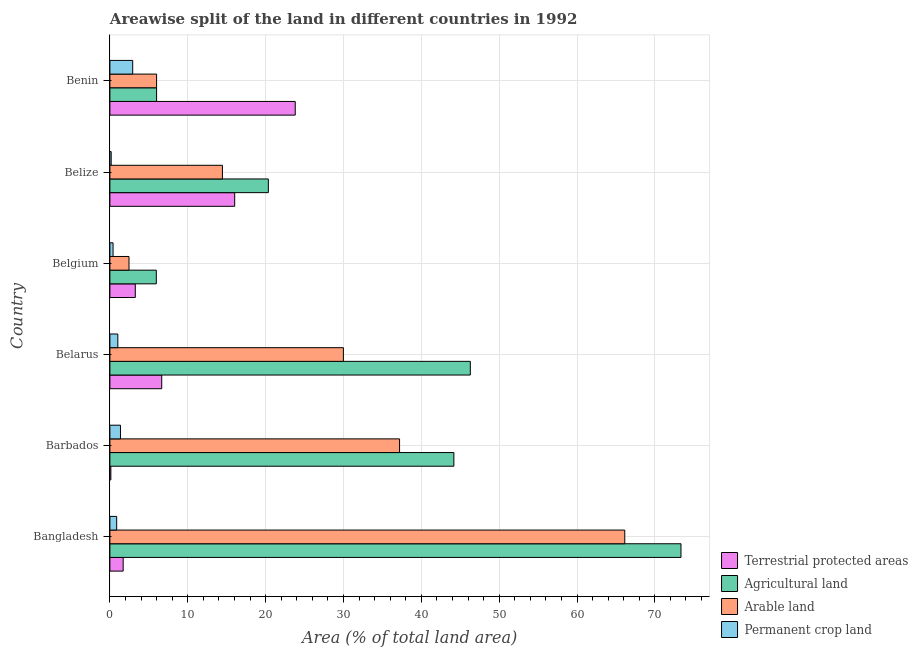How many groups of bars are there?
Provide a succinct answer. 6. Are the number of bars per tick equal to the number of legend labels?
Give a very brief answer. Yes. Are the number of bars on each tick of the Y-axis equal?
Your response must be concise. Yes. What is the label of the 2nd group of bars from the top?
Give a very brief answer. Belize. In how many cases, is the number of bars for a given country not equal to the number of legend labels?
Make the answer very short. 0. What is the percentage of area under permanent crop land in Belgium?
Ensure brevity in your answer.  0.41. Across all countries, what is the maximum percentage of area under permanent crop land?
Offer a very short reply. 2.93. Across all countries, what is the minimum percentage of area under agricultural land?
Keep it short and to the point. 5.96. In which country was the percentage of area under permanent crop land maximum?
Keep it short and to the point. Benin. In which country was the percentage of area under agricultural land minimum?
Offer a terse response. Belgium. What is the total percentage of area under agricultural land in the graph?
Your answer should be compact. 196.16. What is the difference between the percentage of area under agricultural land in Belize and that in Benin?
Keep it short and to the point. 14.35. What is the difference between the percentage of land under terrestrial protection in Benin and the percentage of area under permanent crop land in Barbados?
Provide a succinct answer. 22.45. What is the average percentage of area under arable land per country?
Give a very brief answer. 26.04. What is the difference between the percentage of area under permanent crop land and percentage of land under terrestrial protection in Bangladesh?
Your answer should be very brief. -0.83. What is the ratio of the percentage of area under agricultural land in Barbados to that in Belgium?
Give a very brief answer. 7.41. Is the percentage of area under arable land in Bangladesh less than that in Barbados?
Your response must be concise. No. Is the difference between the percentage of area under agricultural land in Bangladesh and Belize greater than the difference between the percentage of land under terrestrial protection in Bangladesh and Belize?
Provide a succinct answer. Yes. What is the difference between the highest and the second highest percentage of area under agricultural land?
Make the answer very short. 27.06. What is the difference between the highest and the lowest percentage of area under arable land?
Your answer should be very brief. 63.68. In how many countries, is the percentage of area under arable land greater than the average percentage of area under arable land taken over all countries?
Your answer should be very brief. 3. What does the 1st bar from the top in Barbados represents?
Your response must be concise. Permanent crop land. What does the 2nd bar from the bottom in Belarus represents?
Make the answer very short. Agricultural land. How many bars are there?
Give a very brief answer. 24. Are all the bars in the graph horizontal?
Offer a very short reply. Yes. How many countries are there in the graph?
Ensure brevity in your answer.  6. What is the difference between two consecutive major ticks on the X-axis?
Provide a short and direct response. 10. Does the graph contain any zero values?
Offer a very short reply. No. Does the graph contain grids?
Your answer should be compact. Yes. Where does the legend appear in the graph?
Give a very brief answer. Bottom right. What is the title of the graph?
Keep it short and to the point. Areawise split of the land in different countries in 1992. Does "Building human resources" appear as one of the legend labels in the graph?
Your response must be concise. No. What is the label or title of the X-axis?
Ensure brevity in your answer.  Area (% of total land area). What is the Area (% of total land area) of Terrestrial protected areas in Bangladesh?
Offer a very short reply. 1.71. What is the Area (% of total land area) of Agricultural land in Bangladesh?
Provide a short and direct response. 73.36. What is the Area (% of total land area) of Arable land in Bangladesh?
Keep it short and to the point. 66.14. What is the Area (% of total land area) of Permanent crop land in Bangladesh?
Make the answer very short. 0.87. What is the Area (% of total land area) in Terrestrial protected areas in Barbados?
Your answer should be compact. 0.12. What is the Area (% of total land area) of Agricultural land in Barbados?
Keep it short and to the point. 44.19. What is the Area (% of total land area) of Arable land in Barbados?
Make the answer very short. 37.21. What is the Area (% of total land area) of Permanent crop land in Barbados?
Your answer should be very brief. 1.36. What is the Area (% of total land area) of Terrestrial protected areas in Belarus?
Provide a short and direct response. 6.66. What is the Area (% of total land area) of Agricultural land in Belarus?
Keep it short and to the point. 46.3. What is the Area (% of total land area) of Arable land in Belarus?
Keep it short and to the point. 29.99. What is the Area (% of total land area) in Permanent crop land in Belarus?
Provide a short and direct response. 1.02. What is the Area (% of total land area) in Terrestrial protected areas in Belgium?
Provide a short and direct response. 3.26. What is the Area (% of total land area) in Agricultural land in Belgium?
Offer a very short reply. 5.96. What is the Area (% of total land area) in Arable land in Belgium?
Your answer should be very brief. 2.46. What is the Area (% of total land area) of Permanent crop land in Belgium?
Keep it short and to the point. 0.41. What is the Area (% of total land area) of Terrestrial protected areas in Belize?
Provide a short and direct response. 16.03. What is the Area (% of total land area) in Agricultural land in Belize?
Ensure brevity in your answer.  20.35. What is the Area (% of total land area) in Arable land in Belize?
Ensure brevity in your answer.  14.46. What is the Area (% of total land area) of Permanent crop land in Belize?
Make the answer very short. 0.17. What is the Area (% of total land area) in Terrestrial protected areas in Benin?
Your response must be concise. 23.81. What is the Area (% of total land area) in Agricultural land in Benin?
Your answer should be very brief. 6. What is the Area (% of total land area) in Permanent crop land in Benin?
Offer a terse response. 2.93. Across all countries, what is the maximum Area (% of total land area) of Terrestrial protected areas?
Your answer should be compact. 23.81. Across all countries, what is the maximum Area (% of total land area) in Agricultural land?
Ensure brevity in your answer.  73.36. Across all countries, what is the maximum Area (% of total land area) of Arable land?
Offer a very short reply. 66.14. Across all countries, what is the maximum Area (% of total land area) of Permanent crop land?
Ensure brevity in your answer.  2.93. Across all countries, what is the minimum Area (% of total land area) of Terrestrial protected areas?
Keep it short and to the point. 0.12. Across all countries, what is the minimum Area (% of total land area) in Agricultural land?
Offer a very short reply. 5.96. Across all countries, what is the minimum Area (% of total land area) in Arable land?
Provide a succinct answer. 2.46. Across all countries, what is the minimum Area (% of total land area) in Permanent crop land?
Your answer should be compact. 0.17. What is the total Area (% of total land area) in Terrestrial protected areas in the graph?
Ensure brevity in your answer.  51.59. What is the total Area (% of total land area) of Agricultural land in the graph?
Give a very brief answer. 196.16. What is the total Area (% of total land area) in Arable land in the graph?
Offer a terse response. 156.25. What is the total Area (% of total land area) of Permanent crop land in the graph?
Your response must be concise. 6.75. What is the difference between the Area (% of total land area) of Terrestrial protected areas in Bangladesh and that in Barbados?
Make the answer very short. 1.58. What is the difference between the Area (% of total land area) in Agricultural land in Bangladesh and that in Barbados?
Your answer should be very brief. 29.17. What is the difference between the Area (% of total land area) in Arable land in Bangladesh and that in Barbados?
Make the answer very short. 28.93. What is the difference between the Area (% of total land area) of Permanent crop land in Bangladesh and that in Barbados?
Your response must be concise. -0.49. What is the difference between the Area (% of total land area) in Terrestrial protected areas in Bangladesh and that in Belarus?
Keep it short and to the point. -4.95. What is the difference between the Area (% of total land area) in Agricultural land in Bangladesh and that in Belarus?
Your answer should be compact. 27.06. What is the difference between the Area (% of total land area) of Arable land in Bangladesh and that in Belarus?
Ensure brevity in your answer.  36.14. What is the difference between the Area (% of total land area) in Permanent crop land in Bangladesh and that in Belarus?
Give a very brief answer. -0.15. What is the difference between the Area (% of total land area) of Terrestrial protected areas in Bangladesh and that in Belgium?
Offer a very short reply. -1.56. What is the difference between the Area (% of total land area) in Agricultural land in Bangladesh and that in Belgium?
Give a very brief answer. 67.4. What is the difference between the Area (% of total land area) of Arable land in Bangladesh and that in Belgium?
Your answer should be very brief. 63.68. What is the difference between the Area (% of total land area) in Permanent crop land in Bangladesh and that in Belgium?
Ensure brevity in your answer.  0.47. What is the difference between the Area (% of total land area) of Terrestrial protected areas in Bangladesh and that in Belize?
Provide a short and direct response. -14.32. What is the difference between the Area (% of total land area) in Agricultural land in Bangladesh and that in Belize?
Provide a succinct answer. 53.01. What is the difference between the Area (% of total land area) of Arable land in Bangladesh and that in Belize?
Ensure brevity in your answer.  51.68. What is the difference between the Area (% of total land area) in Permanent crop land in Bangladesh and that in Belize?
Your response must be concise. 0.71. What is the difference between the Area (% of total land area) of Terrestrial protected areas in Bangladesh and that in Benin?
Offer a terse response. -22.1. What is the difference between the Area (% of total land area) in Agricultural land in Bangladesh and that in Benin?
Make the answer very short. 67.36. What is the difference between the Area (% of total land area) of Arable land in Bangladesh and that in Benin?
Your answer should be very brief. 60.14. What is the difference between the Area (% of total land area) in Permanent crop land in Bangladesh and that in Benin?
Offer a very short reply. -2.06. What is the difference between the Area (% of total land area) in Terrestrial protected areas in Barbados and that in Belarus?
Your answer should be compact. -6.54. What is the difference between the Area (% of total land area) in Agricultural land in Barbados and that in Belarus?
Make the answer very short. -2.11. What is the difference between the Area (% of total land area) in Arable land in Barbados and that in Belarus?
Provide a succinct answer. 7.22. What is the difference between the Area (% of total land area) in Permanent crop land in Barbados and that in Belarus?
Provide a short and direct response. 0.34. What is the difference between the Area (% of total land area) of Terrestrial protected areas in Barbados and that in Belgium?
Give a very brief answer. -3.14. What is the difference between the Area (% of total land area) in Agricultural land in Barbados and that in Belgium?
Your answer should be compact. 38.22. What is the difference between the Area (% of total land area) of Arable land in Barbados and that in Belgium?
Ensure brevity in your answer.  34.75. What is the difference between the Area (% of total land area) in Permanent crop land in Barbados and that in Belgium?
Keep it short and to the point. 0.95. What is the difference between the Area (% of total land area) in Terrestrial protected areas in Barbados and that in Belize?
Offer a terse response. -15.91. What is the difference between the Area (% of total land area) of Agricultural land in Barbados and that in Belize?
Ensure brevity in your answer.  23.83. What is the difference between the Area (% of total land area) of Arable land in Barbados and that in Belize?
Offer a very short reply. 22.75. What is the difference between the Area (% of total land area) of Permanent crop land in Barbados and that in Belize?
Provide a short and direct response. 1.19. What is the difference between the Area (% of total land area) in Terrestrial protected areas in Barbados and that in Benin?
Ensure brevity in your answer.  -23.68. What is the difference between the Area (% of total land area) in Agricultural land in Barbados and that in Benin?
Your answer should be very brief. 38.19. What is the difference between the Area (% of total land area) in Arable land in Barbados and that in Benin?
Provide a succinct answer. 31.21. What is the difference between the Area (% of total land area) in Permanent crop land in Barbados and that in Benin?
Ensure brevity in your answer.  -1.57. What is the difference between the Area (% of total land area) of Terrestrial protected areas in Belarus and that in Belgium?
Provide a succinct answer. 3.4. What is the difference between the Area (% of total land area) of Agricultural land in Belarus and that in Belgium?
Keep it short and to the point. 40.34. What is the difference between the Area (% of total land area) of Arable land in Belarus and that in Belgium?
Your response must be concise. 27.54. What is the difference between the Area (% of total land area) in Permanent crop land in Belarus and that in Belgium?
Ensure brevity in your answer.  0.61. What is the difference between the Area (% of total land area) in Terrestrial protected areas in Belarus and that in Belize?
Provide a short and direct response. -9.37. What is the difference between the Area (% of total land area) of Agricultural land in Belarus and that in Belize?
Your answer should be very brief. 25.94. What is the difference between the Area (% of total land area) in Arable land in Belarus and that in Belize?
Your answer should be compact. 15.54. What is the difference between the Area (% of total land area) of Permanent crop land in Belarus and that in Belize?
Your answer should be compact. 0.85. What is the difference between the Area (% of total land area) in Terrestrial protected areas in Belarus and that in Benin?
Your response must be concise. -17.15. What is the difference between the Area (% of total land area) of Agricultural land in Belarus and that in Benin?
Your response must be concise. 40.3. What is the difference between the Area (% of total land area) of Arable land in Belarus and that in Benin?
Ensure brevity in your answer.  23.99. What is the difference between the Area (% of total land area) of Permanent crop land in Belarus and that in Benin?
Your answer should be very brief. -1.91. What is the difference between the Area (% of total land area) of Terrestrial protected areas in Belgium and that in Belize?
Your answer should be compact. -12.77. What is the difference between the Area (% of total land area) in Agricultural land in Belgium and that in Belize?
Your response must be concise. -14.39. What is the difference between the Area (% of total land area) of Arable land in Belgium and that in Belize?
Your answer should be very brief. -12. What is the difference between the Area (% of total land area) in Permanent crop land in Belgium and that in Belize?
Your response must be concise. 0.24. What is the difference between the Area (% of total land area) of Terrestrial protected areas in Belgium and that in Benin?
Offer a very short reply. -20.54. What is the difference between the Area (% of total land area) in Agricultural land in Belgium and that in Benin?
Keep it short and to the point. -0.04. What is the difference between the Area (% of total land area) of Arable land in Belgium and that in Benin?
Provide a short and direct response. -3.54. What is the difference between the Area (% of total land area) of Permanent crop land in Belgium and that in Benin?
Your answer should be compact. -2.52. What is the difference between the Area (% of total land area) of Terrestrial protected areas in Belize and that in Benin?
Your answer should be very brief. -7.78. What is the difference between the Area (% of total land area) of Agricultural land in Belize and that in Benin?
Offer a terse response. 14.35. What is the difference between the Area (% of total land area) of Arable land in Belize and that in Benin?
Your response must be concise. 8.46. What is the difference between the Area (% of total land area) of Permanent crop land in Belize and that in Benin?
Your response must be concise. -2.76. What is the difference between the Area (% of total land area) of Terrestrial protected areas in Bangladesh and the Area (% of total land area) of Agricultural land in Barbados?
Offer a very short reply. -42.48. What is the difference between the Area (% of total land area) of Terrestrial protected areas in Bangladesh and the Area (% of total land area) of Arable land in Barbados?
Give a very brief answer. -35.5. What is the difference between the Area (% of total land area) of Terrestrial protected areas in Bangladesh and the Area (% of total land area) of Permanent crop land in Barbados?
Give a very brief answer. 0.35. What is the difference between the Area (% of total land area) of Agricultural land in Bangladesh and the Area (% of total land area) of Arable land in Barbados?
Your response must be concise. 36.15. What is the difference between the Area (% of total land area) of Agricultural land in Bangladesh and the Area (% of total land area) of Permanent crop land in Barbados?
Your answer should be very brief. 72. What is the difference between the Area (% of total land area) in Arable land in Bangladesh and the Area (% of total land area) in Permanent crop land in Barbados?
Offer a terse response. 64.78. What is the difference between the Area (% of total land area) of Terrestrial protected areas in Bangladesh and the Area (% of total land area) of Agricultural land in Belarus?
Your response must be concise. -44.59. What is the difference between the Area (% of total land area) of Terrestrial protected areas in Bangladesh and the Area (% of total land area) of Arable land in Belarus?
Keep it short and to the point. -28.29. What is the difference between the Area (% of total land area) of Terrestrial protected areas in Bangladesh and the Area (% of total land area) of Permanent crop land in Belarus?
Provide a short and direct response. 0.69. What is the difference between the Area (% of total land area) of Agricultural land in Bangladesh and the Area (% of total land area) of Arable land in Belarus?
Offer a very short reply. 43.36. What is the difference between the Area (% of total land area) in Agricultural land in Bangladesh and the Area (% of total land area) in Permanent crop land in Belarus?
Your answer should be compact. 72.34. What is the difference between the Area (% of total land area) in Arable land in Bangladesh and the Area (% of total land area) in Permanent crop land in Belarus?
Your answer should be compact. 65.12. What is the difference between the Area (% of total land area) in Terrestrial protected areas in Bangladesh and the Area (% of total land area) in Agricultural land in Belgium?
Your answer should be compact. -4.26. What is the difference between the Area (% of total land area) of Terrestrial protected areas in Bangladesh and the Area (% of total land area) of Arable land in Belgium?
Provide a succinct answer. -0.75. What is the difference between the Area (% of total land area) in Terrestrial protected areas in Bangladesh and the Area (% of total land area) in Permanent crop land in Belgium?
Offer a terse response. 1.3. What is the difference between the Area (% of total land area) in Agricultural land in Bangladesh and the Area (% of total land area) in Arable land in Belgium?
Your answer should be very brief. 70.9. What is the difference between the Area (% of total land area) in Agricultural land in Bangladesh and the Area (% of total land area) in Permanent crop land in Belgium?
Keep it short and to the point. 72.95. What is the difference between the Area (% of total land area) in Arable land in Bangladesh and the Area (% of total land area) in Permanent crop land in Belgium?
Your answer should be very brief. 65.73. What is the difference between the Area (% of total land area) of Terrestrial protected areas in Bangladesh and the Area (% of total land area) of Agricultural land in Belize?
Provide a succinct answer. -18.65. What is the difference between the Area (% of total land area) of Terrestrial protected areas in Bangladesh and the Area (% of total land area) of Arable land in Belize?
Keep it short and to the point. -12.75. What is the difference between the Area (% of total land area) in Terrestrial protected areas in Bangladesh and the Area (% of total land area) in Permanent crop land in Belize?
Your answer should be compact. 1.54. What is the difference between the Area (% of total land area) of Agricultural land in Bangladesh and the Area (% of total land area) of Arable land in Belize?
Ensure brevity in your answer.  58.9. What is the difference between the Area (% of total land area) in Agricultural land in Bangladesh and the Area (% of total land area) in Permanent crop land in Belize?
Make the answer very short. 73.19. What is the difference between the Area (% of total land area) of Arable land in Bangladesh and the Area (% of total land area) of Permanent crop land in Belize?
Your response must be concise. 65.97. What is the difference between the Area (% of total land area) of Terrestrial protected areas in Bangladesh and the Area (% of total land area) of Agricultural land in Benin?
Provide a succinct answer. -4.29. What is the difference between the Area (% of total land area) of Terrestrial protected areas in Bangladesh and the Area (% of total land area) of Arable land in Benin?
Give a very brief answer. -4.29. What is the difference between the Area (% of total land area) of Terrestrial protected areas in Bangladesh and the Area (% of total land area) of Permanent crop land in Benin?
Provide a succinct answer. -1.22. What is the difference between the Area (% of total land area) in Agricultural land in Bangladesh and the Area (% of total land area) in Arable land in Benin?
Provide a short and direct response. 67.36. What is the difference between the Area (% of total land area) of Agricultural land in Bangladesh and the Area (% of total land area) of Permanent crop land in Benin?
Provide a succinct answer. 70.43. What is the difference between the Area (% of total land area) of Arable land in Bangladesh and the Area (% of total land area) of Permanent crop land in Benin?
Give a very brief answer. 63.21. What is the difference between the Area (% of total land area) in Terrestrial protected areas in Barbados and the Area (% of total land area) in Agricultural land in Belarus?
Provide a succinct answer. -46.17. What is the difference between the Area (% of total land area) of Terrestrial protected areas in Barbados and the Area (% of total land area) of Arable land in Belarus?
Make the answer very short. -29.87. What is the difference between the Area (% of total land area) in Terrestrial protected areas in Barbados and the Area (% of total land area) in Permanent crop land in Belarus?
Provide a short and direct response. -0.9. What is the difference between the Area (% of total land area) in Agricultural land in Barbados and the Area (% of total land area) in Arable land in Belarus?
Provide a succinct answer. 14.19. What is the difference between the Area (% of total land area) of Agricultural land in Barbados and the Area (% of total land area) of Permanent crop land in Belarus?
Ensure brevity in your answer.  43.17. What is the difference between the Area (% of total land area) in Arable land in Barbados and the Area (% of total land area) in Permanent crop land in Belarus?
Ensure brevity in your answer.  36.19. What is the difference between the Area (% of total land area) in Terrestrial protected areas in Barbados and the Area (% of total land area) in Agricultural land in Belgium?
Your answer should be compact. -5.84. What is the difference between the Area (% of total land area) in Terrestrial protected areas in Barbados and the Area (% of total land area) in Arable land in Belgium?
Give a very brief answer. -2.33. What is the difference between the Area (% of total land area) in Terrestrial protected areas in Barbados and the Area (% of total land area) in Permanent crop land in Belgium?
Your answer should be compact. -0.28. What is the difference between the Area (% of total land area) of Agricultural land in Barbados and the Area (% of total land area) of Arable land in Belgium?
Provide a succinct answer. 41.73. What is the difference between the Area (% of total land area) in Agricultural land in Barbados and the Area (% of total land area) in Permanent crop land in Belgium?
Your response must be concise. 43.78. What is the difference between the Area (% of total land area) in Arable land in Barbados and the Area (% of total land area) in Permanent crop land in Belgium?
Your answer should be compact. 36.8. What is the difference between the Area (% of total land area) in Terrestrial protected areas in Barbados and the Area (% of total land area) in Agricultural land in Belize?
Your answer should be very brief. -20.23. What is the difference between the Area (% of total land area) in Terrestrial protected areas in Barbados and the Area (% of total land area) in Arable land in Belize?
Your response must be concise. -14.33. What is the difference between the Area (% of total land area) in Terrestrial protected areas in Barbados and the Area (% of total land area) in Permanent crop land in Belize?
Provide a short and direct response. -0.04. What is the difference between the Area (% of total land area) in Agricultural land in Barbados and the Area (% of total land area) in Arable land in Belize?
Offer a terse response. 29.73. What is the difference between the Area (% of total land area) of Agricultural land in Barbados and the Area (% of total land area) of Permanent crop land in Belize?
Make the answer very short. 44.02. What is the difference between the Area (% of total land area) in Arable land in Barbados and the Area (% of total land area) in Permanent crop land in Belize?
Make the answer very short. 37.04. What is the difference between the Area (% of total land area) in Terrestrial protected areas in Barbados and the Area (% of total land area) in Agricultural land in Benin?
Your answer should be compact. -5.88. What is the difference between the Area (% of total land area) in Terrestrial protected areas in Barbados and the Area (% of total land area) in Arable land in Benin?
Provide a succinct answer. -5.88. What is the difference between the Area (% of total land area) in Terrestrial protected areas in Barbados and the Area (% of total land area) in Permanent crop land in Benin?
Provide a short and direct response. -2.81. What is the difference between the Area (% of total land area) in Agricultural land in Barbados and the Area (% of total land area) in Arable land in Benin?
Ensure brevity in your answer.  38.19. What is the difference between the Area (% of total land area) of Agricultural land in Barbados and the Area (% of total land area) of Permanent crop land in Benin?
Provide a short and direct response. 41.26. What is the difference between the Area (% of total land area) in Arable land in Barbados and the Area (% of total land area) in Permanent crop land in Benin?
Provide a short and direct response. 34.28. What is the difference between the Area (% of total land area) in Terrestrial protected areas in Belarus and the Area (% of total land area) in Agricultural land in Belgium?
Provide a succinct answer. 0.7. What is the difference between the Area (% of total land area) in Terrestrial protected areas in Belarus and the Area (% of total land area) in Arable land in Belgium?
Provide a short and direct response. 4.2. What is the difference between the Area (% of total land area) of Terrestrial protected areas in Belarus and the Area (% of total land area) of Permanent crop land in Belgium?
Make the answer very short. 6.25. What is the difference between the Area (% of total land area) of Agricultural land in Belarus and the Area (% of total land area) of Arable land in Belgium?
Give a very brief answer. 43.84. What is the difference between the Area (% of total land area) of Agricultural land in Belarus and the Area (% of total land area) of Permanent crop land in Belgium?
Offer a very short reply. 45.89. What is the difference between the Area (% of total land area) in Arable land in Belarus and the Area (% of total land area) in Permanent crop land in Belgium?
Offer a very short reply. 29.59. What is the difference between the Area (% of total land area) of Terrestrial protected areas in Belarus and the Area (% of total land area) of Agricultural land in Belize?
Offer a terse response. -13.69. What is the difference between the Area (% of total land area) of Terrestrial protected areas in Belarus and the Area (% of total land area) of Arable land in Belize?
Keep it short and to the point. -7.8. What is the difference between the Area (% of total land area) of Terrestrial protected areas in Belarus and the Area (% of total land area) of Permanent crop land in Belize?
Offer a terse response. 6.49. What is the difference between the Area (% of total land area) of Agricultural land in Belarus and the Area (% of total land area) of Arable land in Belize?
Give a very brief answer. 31.84. What is the difference between the Area (% of total land area) of Agricultural land in Belarus and the Area (% of total land area) of Permanent crop land in Belize?
Your response must be concise. 46.13. What is the difference between the Area (% of total land area) of Arable land in Belarus and the Area (% of total land area) of Permanent crop land in Belize?
Your response must be concise. 29.83. What is the difference between the Area (% of total land area) of Terrestrial protected areas in Belarus and the Area (% of total land area) of Agricultural land in Benin?
Ensure brevity in your answer.  0.66. What is the difference between the Area (% of total land area) of Terrestrial protected areas in Belarus and the Area (% of total land area) of Arable land in Benin?
Ensure brevity in your answer.  0.66. What is the difference between the Area (% of total land area) in Terrestrial protected areas in Belarus and the Area (% of total land area) in Permanent crop land in Benin?
Your response must be concise. 3.73. What is the difference between the Area (% of total land area) in Agricultural land in Belarus and the Area (% of total land area) in Arable land in Benin?
Offer a very short reply. 40.3. What is the difference between the Area (% of total land area) in Agricultural land in Belarus and the Area (% of total land area) in Permanent crop land in Benin?
Offer a terse response. 43.37. What is the difference between the Area (% of total land area) in Arable land in Belarus and the Area (% of total land area) in Permanent crop land in Benin?
Give a very brief answer. 27.06. What is the difference between the Area (% of total land area) in Terrestrial protected areas in Belgium and the Area (% of total land area) in Agricultural land in Belize?
Give a very brief answer. -17.09. What is the difference between the Area (% of total land area) of Terrestrial protected areas in Belgium and the Area (% of total land area) of Arable land in Belize?
Give a very brief answer. -11.19. What is the difference between the Area (% of total land area) of Terrestrial protected areas in Belgium and the Area (% of total land area) of Permanent crop land in Belize?
Give a very brief answer. 3.1. What is the difference between the Area (% of total land area) in Agricultural land in Belgium and the Area (% of total land area) in Arable land in Belize?
Provide a succinct answer. -8.49. What is the difference between the Area (% of total land area) in Agricultural land in Belgium and the Area (% of total land area) in Permanent crop land in Belize?
Keep it short and to the point. 5.8. What is the difference between the Area (% of total land area) of Arable land in Belgium and the Area (% of total land area) of Permanent crop land in Belize?
Provide a succinct answer. 2.29. What is the difference between the Area (% of total land area) of Terrestrial protected areas in Belgium and the Area (% of total land area) of Agricultural land in Benin?
Offer a terse response. -2.74. What is the difference between the Area (% of total land area) in Terrestrial protected areas in Belgium and the Area (% of total land area) in Arable land in Benin?
Offer a terse response. -2.74. What is the difference between the Area (% of total land area) in Terrestrial protected areas in Belgium and the Area (% of total land area) in Permanent crop land in Benin?
Provide a succinct answer. 0.33. What is the difference between the Area (% of total land area) of Agricultural land in Belgium and the Area (% of total land area) of Arable land in Benin?
Your response must be concise. -0.04. What is the difference between the Area (% of total land area) of Agricultural land in Belgium and the Area (% of total land area) of Permanent crop land in Benin?
Ensure brevity in your answer.  3.03. What is the difference between the Area (% of total land area) in Arable land in Belgium and the Area (% of total land area) in Permanent crop land in Benin?
Your response must be concise. -0.47. What is the difference between the Area (% of total land area) in Terrestrial protected areas in Belize and the Area (% of total land area) in Agricultural land in Benin?
Ensure brevity in your answer.  10.03. What is the difference between the Area (% of total land area) of Terrestrial protected areas in Belize and the Area (% of total land area) of Arable land in Benin?
Ensure brevity in your answer.  10.03. What is the difference between the Area (% of total land area) in Terrestrial protected areas in Belize and the Area (% of total land area) in Permanent crop land in Benin?
Give a very brief answer. 13.1. What is the difference between the Area (% of total land area) of Agricultural land in Belize and the Area (% of total land area) of Arable land in Benin?
Ensure brevity in your answer.  14.35. What is the difference between the Area (% of total land area) of Agricultural land in Belize and the Area (% of total land area) of Permanent crop land in Benin?
Ensure brevity in your answer.  17.42. What is the difference between the Area (% of total land area) in Arable land in Belize and the Area (% of total land area) in Permanent crop land in Benin?
Offer a very short reply. 11.53. What is the average Area (% of total land area) of Terrestrial protected areas per country?
Give a very brief answer. 8.6. What is the average Area (% of total land area) of Agricultural land per country?
Your answer should be compact. 32.69. What is the average Area (% of total land area) in Arable land per country?
Keep it short and to the point. 26.04. What is the average Area (% of total land area) of Permanent crop land per country?
Keep it short and to the point. 1.13. What is the difference between the Area (% of total land area) in Terrestrial protected areas and Area (% of total land area) in Agricultural land in Bangladesh?
Offer a terse response. -71.65. What is the difference between the Area (% of total land area) of Terrestrial protected areas and Area (% of total land area) of Arable land in Bangladesh?
Provide a short and direct response. -64.43. What is the difference between the Area (% of total land area) of Terrestrial protected areas and Area (% of total land area) of Permanent crop land in Bangladesh?
Provide a succinct answer. 0.83. What is the difference between the Area (% of total land area) in Agricultural land and Area (% of total land area) in Arable land in Bangladesh?
Make the answer very short. 7.22. What is the difference between the Area (% of total land area) in Agricultural land and Area (% of total land area) in Permanent crop land in Bangladesh?
Keep it short and to the point. 72.49. What is the difference between the Area (% of total land area) in Arable land and Area (% of total land area) in Permanent crop land in Bangladesh?
Your answer should be compact. 65.26. What is the difference between the Area (% of total land area) of Terrestrial protected areas and Area (% of total land area) of Agricultural land in Barbados?
Offer a terse response. -44.06. What is the difference between the Area (% of total land area) of Terrestrial protected areas and Area (% of total land area) of Arable land in Barbados?
Provide a short and direct response. -37.09. What is the difference between the Area (% of total land area) of Terrestrial protected areas and Area (% of total land area) of Permanent crop land in Barbados?
Keep it short and to the point. -1.23. What is the difference between the Area (% of total land area) of Agricultural land and Area (% of total land area) of Arable land in Barbados?
Your answer should be very brief. 6.98. What is the difference between the Area (% of total land area) in Agricultural land and Area (% of total land area) in Permanent crop land in Barbados?
Provide a succinct answer. 42.83. What is the difference between the Area (% of total land area) of Arable land and Area (% of total land area) of Permanent crop land in Barbados?
Provide a succinct answer. 35.85. What is the difference between the Area (% of total land area) in Terrestrial protected areas and Area (% of total land area) in Agricultural land in Belarus?
Keep it short and to the point. -39.64. What is the difference between the Area (% of total land area) of Terrestrial protected areas and Area (% of total land area) of Arable land in Belarus?
Your answer should be compact. -23.33. What is the difference between the Area (% of total land area) in Terrestrial protected areas and Area (% of total land area) in Permanent crop land in Belarus?
Offer a terse response. 5.64. What is the difference between the Area (% of total land area) of Agricultural land and Area (% of total land area) of Arable land in Belarus?
Ensure brevity in your answer.  16.3. What is the difference between the Area (% of total land area) in Agricultural land and Area (% of total land area) in Permanent crop land in Belarus?
Keep it short and to the point. 45.28. What is the difference between the Area (% of total land area) in Arable land and Area (% of total land area) in Permanent crop land in Belarus?
Offer a terse response. 28.97. What is the difference between the Area (% of total land area) of Terrestrial protected areas and Area (% of total land area) of Agricultural land in Belgium?
Offer a terse response. -2.7. What is the difference between the Area (% of total land area) in Terrestrial protected areas and Area (% of total land area) in Arable land in Belgium?
Make the answer very short. 0.81. What is the difference between the Area (% of total land area) of Terrestrial protected areas and Area (% of total land area) of Permanent crop land in Belgium?
Give a very brief answer. 2.86. What is the difference between the Area (% of total land area) in Agricultural land and Area (% of total land area) in Arable land in Belgium?
Make the answer very short. 3.51. What is the difference between the Area (% of total land area) in Agricultural land and Area (% of total land area) in Permanent crop land in Belgium?
Offer a terse response. 5.56. What is the difference between the Area (% of total land area) in Arable land and Area (% of total land area) in Permanent crop land in Belgium?
Your answer should be compact. 2.05. What is the difference between the Area (% of total land area) of Terrestrial protected areas and Area (% of total land area) of Agricultural land in Belize?
Make the answer very short. -4.32. What is the difference between the Area (% of total land area) of Terrestrial protected areas and Area (% of total land area) of Arable land in Belize?
Keep it short and to the point. 1.57. What is the difference between the Area (% of total land area) in Terrestrial protected areas and Area (% of total land area) in Permanent crop land in Belize?
Your answer should be very brief. 15.86. What is the difference between the Area (% of total land area) in Agricultural land and Area (% of total land area) in Arable land in Belize?
Your answer should be very brief. 5.9. What is the difference between the Area (% of total land area) in Agricultural land and Area (% of total land area) in Permanent crop land in Belize?
Give a very brief answer. 20.19. What is the difference between the Area (% of total land area) in Arable land and Area (% of total land area) in Permanent crop land in Belize?
Your answer should be compact. 14.29. What is the difference between the Area (% of total land area) in Terrestrial protected areas and Area (% of total land area) in Agricultural land in Benin?
Keep it short and to the point. 17.81. What is the difference between the Area (% of total land area) in Terrestrial protected areas and Area (% of total land area) in Arable land in Benin?
Your answer should be compact. 17.81. What is the difference between the Area (% of total land area) of Terrestrial protected areas and Area (% of total land area) of Permanent crop land in Benin?
Keep it short and to the point. 20.88. What is the difference between the Area (% of total land area) in Agricultural land and Area (% of total land area) in Arable land in Benin?
Make the answer very short. 0. What is the difference between the Area (% of total land area) in Agricultural land and Area (% of total land area) in Permanent crop land in Benin?
Keep it short and to the point. 3.07. What is the difference between the Area (% of total land area) of Arable land and Area (% of total land area) of Permanent crop land in Benin?
Provide a succinct answer. 3.07. What is the ratio of the Area (% of total land area) in Terrestrial protected areas in Bangladesh to that in Barbados?
Provide a succinct answer. 13.75. What is the ratio of the Area (% of total land area) of Agricultural land in Bangladesh to that in Barbados?
Your response must be concise. 1.66. What is the ratio of the Area (% of total land area) of Arable land in Bangladesh to that in Barbados?
Provide a short and direct response. 1.78. What is the ratio of the Area (% of total land area) in Permanent crop land in Bangladesh to that in Barbados?
Your answer should be compact. 0.64. What is the ratio of the Area (% of total land area) of Terrestrial protected areas in Bangladesh to that in Belarus?
Provide a short and direct response. 0.26. What is the ratio of the Area (% of total land area) in Agricultural land in Bangladesh to that in Belarus?
Provide a short and direct response. 1.58. What is the ratio of the Area (% of total land area) of Arable land in Bangladesh to that in Belarus?
Provide a short and direct response. 2.21. What is the ratio of the Area (% of total land area) of Permanent crop land in Bangladesh to that in Belarus?
Keep it short and to the point. 0.86. What is the ratio of the Area (% of total land area) of Terrestrial protected areas in Bangladesh to that in Belgium?
Give a very brief answer. 0.52. What is the ratio of the Area (% of total land area) in Agricultural land in Bangladesh to that in Belgium?
Give a very brief answer. 12.3. What is the ratio of the Area (% of total land area) of Arable land in Bangladesh to that in Belgium?
Provide a short and direct response. 26.94. What is the ratio of the Area (% of total land area) in Permanent crop land in Bangladesh to that in Belgium?
Give a very brief answer. 2.15. What is the ratio of the Area (% of total land area) of Terrestrial protected areas in Bangladesh to that in Belize?
Your response must be concise. 0.11. What is the ratio of the Area (% of total land area) of Agricultural land in Bangladesh to that in Belize?
Ensure brevity in your answer.  3.6. What is the ratio of the Area (% of total land area) in Arable land in Bangladesh to that in Belize?
Your answer should be compact. 4.58. What is the ratio of the Area (% of total land area) of Permanent crop land in Bangladesh to that in Belize?
Offer a very short reply. 5.22. What is the ratio of the Area (% of total land area) in Terrestrial protected areas in Bangladesh to that in Benin?
Give a very brief answer. 0.07. What is the ratio of the Area (% of total land area) in Agricultural land in Bangladesh to that in Benin?
Provide a succinct answer. 12.23. What is the ratio of the Area (% of total land area) of Arable land in Bangladesh to that in Benin?
Keep it short and to the point. 11.02. What is the ratio of the Area (% of total land area) in Permanent crop land in Bangladesh to that in Benin?
Provide a succinct answer. 0.3. What is the ratio of the Area (% of total land area) of Terrestrial protected areas in Barbados to that in Belarus?
Provide a short and direct response. 0.02. What is the ratio of the Area (% of total land area) of Agricultural land in Barbados to that in Belarus?
Offer a very short reply. 0.95. What is the ratio of the Area (% of total land area) in Arable land in Barbados to that in Belarus?
Offer a terse response. 1.24. What is the ratio of the Area (% of total land area) of Permanent crop land in Barbados to that in Belarus?
Offer a very short reply. 1.33. What is the ratio of the Area (% of total land area) of Terrestrial protected areas in Barbados to that in Belgium?
Give a very brief answer. 0.04. What is the ratio of the Area (% of total land area) of Agricultural land in Barbados to that in Belgium?
Your response must be concise. 7.41. What is the ratio of the Area (% of total land area) in Arable land in Barbados to that in Belgium?
Provide a short and direct response. 15.16. What is the ratio of the Area (% of total land area) of Permanent crop land in Barbados to that in Belgium?
Your response must be concise. 3.34. What is the ratio of the Area (% of total land area) in Terrestrial protected areas in Barbados to that in Belize?
Give a very brief answer. 0.01. What is the ratio of the Area (% of total land area) in Agricultural land in Barbados to that in Belize?
Make the answer very short. 2.17. What is the ratio of the Area (% of total land area) in Arable land in Barbados to that in Belize?
Make the answer very short. 2.57. What is the ratio of the Area (% of total land area) in Permanent crop land in Barbados to that in Belize?
Your answer should be very brief. 8.13. What is the ratio of the Area (% of total land area) in Terrestrial protected areas in Barbados to that in Benin?
Make the answer very short. 0.01. What is the ratio of the Area (% of total land area) in Agricultural land in Barbados to that in Benin?
Your response must be concise. 7.36. What is the ratio of the Area (% of total land area) of Arable land in Barbados to that in Benin?
Ensure brevity in your answer.  6.2. What is the ratio of the Area (% of total land area) in Permanent crop land in Barbados to that in Benin?
Your answer should be very brief. 0.46. What is the ratio of the Area (% of total land area) in Terrestrial protected areas in Belarus to that in Belgium?
Your response must be concise. 2.04. What is the ratio of the Area (% of total land area) in Agricultural land in Belarus to that in Belgium?
Keep it short and to the point. 7.77. What is the ratio of the Area (% of total land area) of Arable land in Belarus to that in Belgium?
Give a very brief answer. 12.22. What is the ratio of the Area (% of total land area) of Permanent crop land in Belarus to that in Belgium?
Give a very brief answer. 2.51. What is the ratio of the Area (% of total land area) in Terrestrial protected areas in Belarus to that in Belize?
Offer a terse response. 0.42. What is the ratio of the Area (% of total land area) of Agricultural land in Belarus to that in Belize?
Make the answer very short. 2.27. What is the ratio of the Area (% of total land area) in Arable land in Belarus to that in Belize?
Offer a very short reply. 2.07. What is the ratio of the Area (% of total land area) of Permanent crop land in Belarus to that in Belize?
Provide a short and direct response. 6.1. What is the ratio of the Area (% of total land area) in Terrestrial protected areas in Belarus to that in Benin?
Your response must be concise. 0.28. What is the ratio of the Area (% of total land area) of Agricultural land in Belarus to that in Benin?
Keep it short and to the point. 7.72. What is the ratio of the Area (% of total land area) in Arable land in Belarus to that in Benin?
Ensure brevity in your answer.  5. What is the ratio of the Area (% of total land area) in Permanent crop land in Belarus to that in Benin?
Give a very brief answer. 0.35. What is the ratio of the Area (% of total land area) in Terrestrial protected areas in Belgium to that in Belize?
Offer a terse response. 0.2. What is the ratio of the Area (% of total land area) of Agricultural land in Belgium to that in Belize?
Your response must be concise. 0.29. What is the ratio of the Area (% of total land area) of Arable land in Belgium to that in Belize?
Keep it short and to the point. 0.17. What is the ratio of the Area (% of total land area) of Permanent crop land in Belgium to that in Belize?
Offer a terse response. 2.43. What is the ratio of the Area (% of total land area) of Terrestrial protected areas in Belgium to that in Benin?
Ensure brevity in your answer.  0.14. What is the ratio of the Area (% of total land area) in Agricultural land in Belgium to that in Benin?
Offer a very short reply. 0.99. What is the ratio of the Area (% of total land area) of Arable land in Belgium to that in Benin?
Give a very brief answer. 0.41. What is the ratio of the Area (% of total land area) in Permanent crop land in Belgium to that in Benin?
Provide a succinct answer. 0.14. What is the ratio of the Area (% of total land area) of Terrestrial protected areas in Belize to that in Benin?
Offer a very short reply. 0.67. What is the ratio of the Area (% of total land area) of Agricultural land in Belize to that in Benin?
Your answer should be very brief. 3.39. What is the ratio of the Area (% of total land area) in Arable land in Belize to that in Benin?
Your answer should be compact. 2.41. What is the ratio of the Area (% of total land area) of Permanent crop land in Belize to that in Benin?
Offer a very short reply. 0.06. What is the difference between the highest and the second highest Area (% of total land area) of Terrestrial protected areas?
Your answer should be very brief. 7.78. What is the difference between the highest and the second highest Area (% of total land area) of Agricultural land?
Provide a short and direct response. 27.06. What is the difference between the highest and the second highest Area (% of total land area) in Arable land?
Ensure brevity in your answer.  28.93. What is the difference between the highest and the second highest Area (% of total land area) of Permanent crop land?
Make the answer very short. 1.57. What is the difference between the highest and the lowest Area (% of total land area) in Terrestrial protected areas?
Your answer should be very brief. 23.68. What is the difference between the highest and the lowest Area (% of total land area) of Agricultural land?
Your answer should be compact. 67.4. What is the difference between the highest and the lowest Area (% of total land area) in Arable land?
Provide a short and direct response. 63.68. What is the difference between the highest and the lowest Area (% of total land area) in Permanent crop land?
Give a very brief answer. 2.76. 